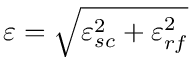Convert formula to latex. <formula><loc_0><loc_0><loc_500><loc_500>\varepsilon = \sqrt { \varepsilon _ { s c } ^ { 2 } + \varepsilon _ { r f } ^ { 2 } }</formula> 